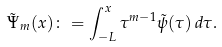Convert formula to latex. <formula><loc_0><loc_0><loc_500><loc_500>\tilde { \Psi } _ { m } ( x ) \colon = \int _ { - L } ^ { x } \tau ^ { m - 1 } \tilde { \psi } ( \tau ) \, d \tau .</formula> 